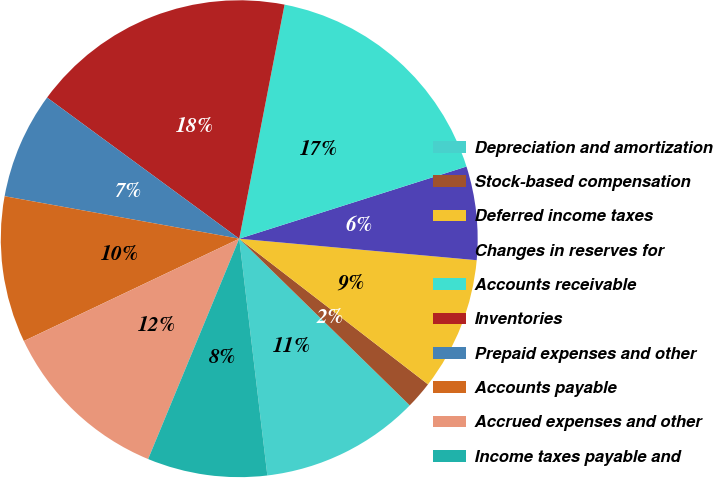Convert chart. <chart><loc_0><loc_0><loc_500><loc_500><pie_chart><fcel>Depreciation and amortization<fcel>Stock-based compensation<fcel>Deferred income taxes<fcel>Changes in reserves for<fcel>Accounts receivable<fcel>Inventories<fcel>Prepaid expenses and other<fcel>Accounts payable<fcel>Accrued expenses and other<fcel>Income taxes payable and<nl><fcel>10.8%<fcel>1.86%<fcel>9.02%<fcel>6.33%<fcel>17.06%<fcel>17.96%<fcel>7.23%<fcel>9.91%<fcel>11.7%<fcel>8.12%<nl></chart> 